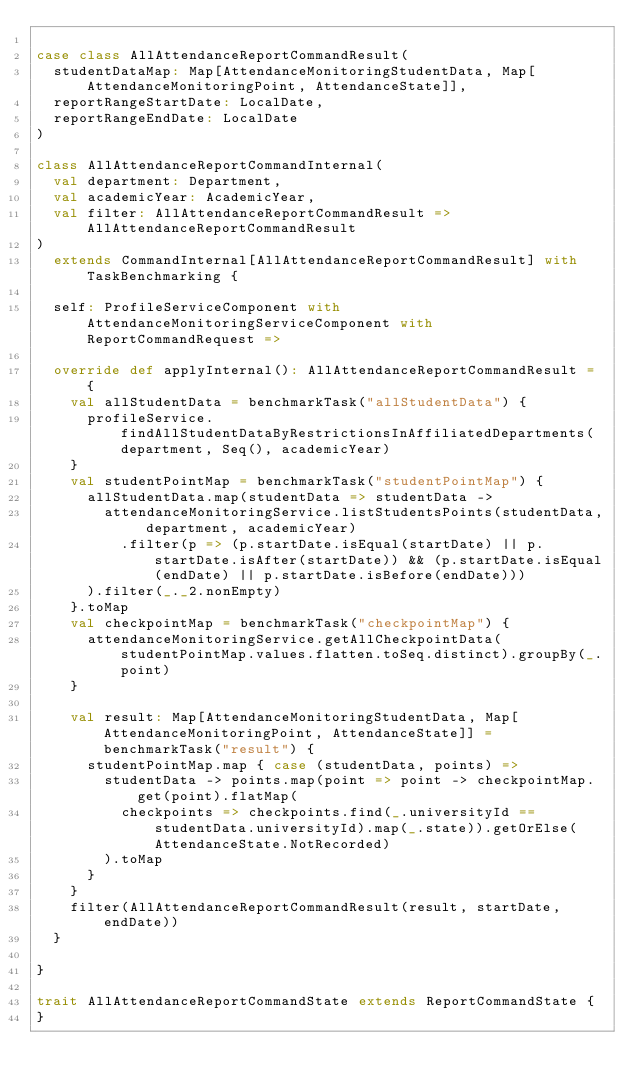<code> <loc_0><loc_0><loc_500><loc_500><_Scala_>
case class AllAttendanceReportCommandResult(
  studentDataMap: Map[AttendanceMonitoringStudentData, Map[AttendanceMonitoringPoint, AttendanceState]],
  reportRangeStartDate: LocalDate,
  reportRangeEndDate: LocalDate
)

class AllAttendanceReportCommandInternal(
  val department: Department,
  val academicYear: AcademicYear,
  val filter: AllAttendanceReportCommandResult => AllAttendanceReportCommandResult
)
  extends CommandInternal[AllAttendanceReportCommandResult] with TaskBenchmarking {

  self: ProfileServiceComponent with AttendanceMonitoringServiceComponent with ReportCommandRequest =>

  override def applyInternal(): AllAttendanceReportCommandResult = {
    val allStudentData = benchmarkTask("allStudentData") {
      profileService.findAllStudentDataByRestrictionsInAffiliatedDepartments(department, Seq(), academicYear)
    }
    val studentPointMap = benchmarkTask("studentPointMap") {
      allStudentData.map(studentData => studentData ->
        attendanceMonitoringService.listStudentsPoints(studentData, department, academicYear)
          .filter(p => (p.startDate.isEqual(startDate) || p.startDate.isAfter(startDate)) && (p.startDate.isEqual(endDate) || p.startDate.isBefore(endDate)))
      ).filter(_._2.nonEmpty)
    }.toMap
    val checkpointMap = benchmarkTask("checkpointMap") {
      attendanceMonitoringService.getAllCheckpointData(studentPointMap.values.flatten.toSeq.distinct).groupBy(_.point)
    }

    val result: Map[AttendanceMonitoringStudentData, Map[AttendanceMonitoringPoint, AttendanceState]] = benchmarkTask("result") {
      studentPointMap.map { case (studentData, points) =>
        studentData -> points.map(point => point -> checkpointMap.get(point).flatMap(
          checkpoints => checkpoints.find(_.universityId == studentData.universityId).map(_.state)).getOrElse(AttendanceState.NotRecorded)
        ).toMap
      }
    }
    filter(AllAttendanceReportCommandResult(result, startDate, endDate))
  }

}

trait AllAttendanceReportCommandState extends ReportCommandState {
}
</code> 